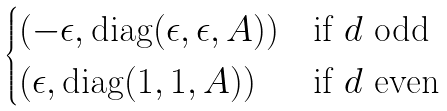Convert formula to latex. <formula><loc_0><loc_0><loc_500><loc_500>\begin{cases} ( - \epsilon , \text {diag} ( \epsilon , \epsilon , A ) ) & \text {if $d$ odd} \\ ( \epsilon , \text {diag} ( 1 , 1 , A ) ) & \text {if $d$ even} \end{cases}</formula> 